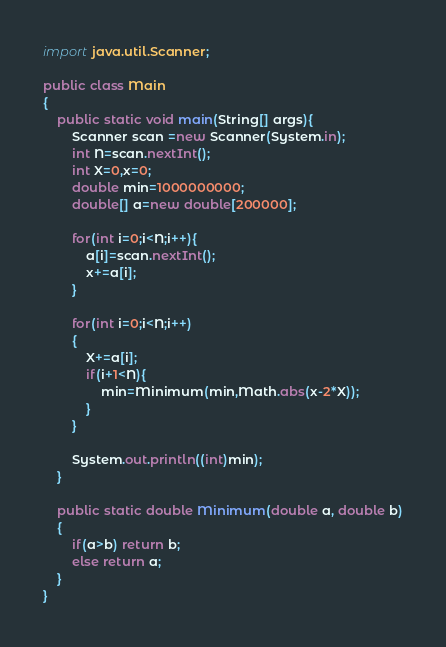<code> <loc_0><loc_0><loc_500><loc_500><_Java_>import java.util.Scanner;

public class Main
{
    public static void main(String[] args){
        Scanner scan =new Scanner(System.in);
        int N=scan.nextInt();
        int X=0,x=0;
        double min=1000000000;
        double[] a=new double[200000];

        for(int i=0;i<N;i++){
            a[i]=scan.nextInt();
            x+=a[i];
        }

        for(int i=0;i<N;i++)
        {
            X+=a[i];
            if(i+1<N){
                min=Minimum(min,Math.abs(x-2*X));
            }
        }

        System.out.println((int)min);
    }

    public static double Minimum(double a, double b)
    {
        if(a>b) return b;
        else return a;
    }
}</code> 